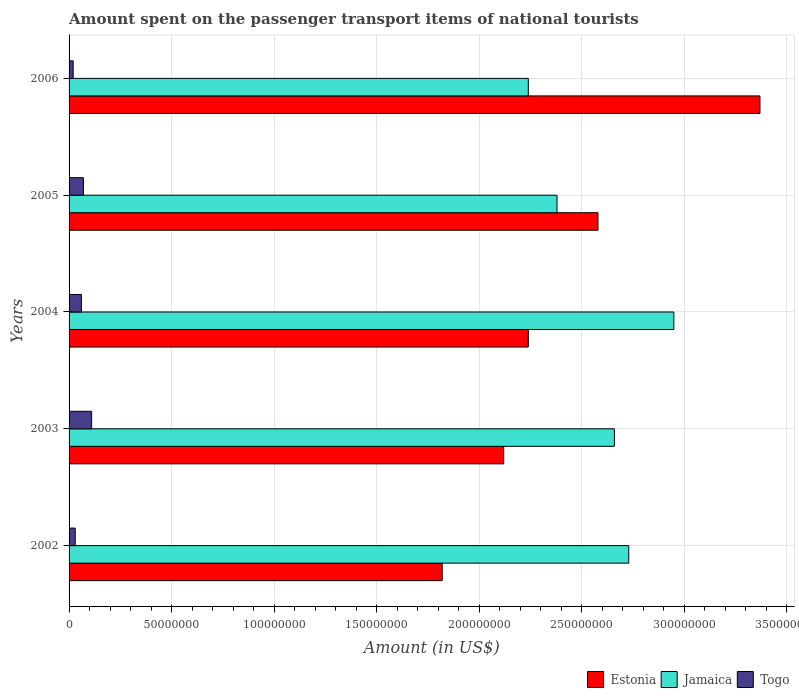What is the label of the 1st group of bars from the top?
Your answer should be compact. 2006. What is the amount spent on the passenger transport items of national tourists in Estonia in 2006?
Your answer should be compact. 3.37e+08. Across all years, what is the maximum amount spent on the passenger transport items of national tourists in Jamaica?
Offer a terse response. 2.95e+08. Across all years, what is the minimum amount spent on the passenger transport items of national tourists in Estonia?
Your answer should be compact. 1.82e+08. In which year was the amount spent on the passenger transport items of national tourists in Estonia maximum?
Your response must be concise. 2006. In which year was the amount spent on the passenger transport items of national tourists in Jamaica minimum?
Keep it short and to the point. 2006. What is the total amount spent on the passenger transport items of national tourists in Estonia in the graph?
Your answer should be very brief. 1.21e+09. What is the difference between the amount spent on the passenger transport items of national tourists in Jamaica in 2002 and that in 2005?
Your response must be concise. 3.50e+07. What is the difference between the amount spent on the passenger transport items of national tourists in Estonia in 2004 and the amount spent on the passenger transport items of national tourists in Jamaica in 2006?
Offer a terse response. 0. What is the average amount spent on the passenger transport items of national tourists in Togo per year?
Your response must be concise. 5.80e+06. In the year 2002, what is the difference between the amount spent on the passenger transport items of national tourists in Togo and amount spent on the passenger transport items of national tourists in Jamaica?
Ensure brevity in your answer.  -2.70e+08. In how many years, is the amount spent on the passenger transport items of national tourists in Estonia greater than 120000000 US$?
Your answer should be compact. 5. What is the ratio of the amount spent on the passenger transport items of national tourists in Estonia in 2002 to that in 2003?
Your response must be concise. 0.86. What is the difference between the highest and the second highest amount spent on the passenger transport items of national tourists in Estonia?
Your answer should be very brief. 7.90e+07. What is the difference between the highest and the lowest amount spent on the passenger transport items of national tourists in Togo?
Offer a terse response. 9.00e+06. Is the sum of the amount spent on the passenger transport items of national tourists in Togo in 2003 and 2006 greater than the maximum amount spent on the passenger transport items of national tourists in Estonia across all years?
Your response must be concise. No. What does the 3rd bar from the top in 2003 represents?
Your answer should be very brief. Estonia. What does the 2nd bar from the bottom in 2003 represents?
Make the answer very short. Jamaica. How many bars are there?
Offer a terse response. 15. Are the values on the major ticks of X-axis written in scientific E-notation?
Offer a terse response. No. Does the graph contain any zero values?
Make the answer very short. No. Where does the legend appear in the graph?
Your response must be concise. Bottom right. What is the title of the graph?
Provide a succinct answer. Amount spent on the passenger transport items of national tourists. What is the label or title of the Y-axis?
Ensure brevity in your answer.  Years. What is the Amount (in US$) of Estonia in 2002?
Your answer should be very brief. 1.82e+08. What is the Amount (in US$) in Jamaica in 2002?
Your answer should be very brief. 2.73e+08. What is the Amount (in US$) in Estonia in 2003?
Keep it short and to the point. 2.12e+08. What is the Amount (in US$) in Jamaica in 2003?
Provide a succinct answer. 2.66e+08. What is the Amount (in US$) in Togo in 2003?
Offer a very short reply. 1.10e+07. What is the Amount (in US$) of Estonia in 2004?
Your answer should be very brief. 2.24e+08. What is the Amount (in US$) in Jamaica in 2004?
Your response must be concise. 2.95e+08. What is the Amount (in US$) in Estonia in 2005?
Provide a short and direct response. 2.58e+08. What is the Amount (in US$) of Jamaica in 2005?
Offer a terse response. 2.38e+08. What is the Amount (in US$) of Togo in 2005?
Provide a succinct answer. 7.00e+06. What is the Amount (in US$) in Estonia in 2006?
Offer a terse response. 3.37e+08. What is the Amount (in US$) of Jamaica in 2006?
Keep it short and to the point. 2.24e+08. Across all years, what is the maximum Amount (in US$) in Estonia?
Ensure brevity in your answer.  3.37e+08. Across all years, what is the maximum Amount (in US$) of Jamaica?
Give a very brief answer. 2.95e+08. Across all years, what is the maximum Amount (in US$) in Togo?
Offer a terse response. 1.10e+07. Across all years, what is the minimum Amount (in US$) in Estonia?
Your answer should be compact. 1.82e+08. Across all years, what is the minimum Amount (in US$) of Jamaica?
Ensure brevity in your answer.  2.24e+08. What is the total Amount (in US$) of Estonia in the graph?
Offer a very short reply. 1.21e+09. What is the total Amount (in US$) of Jamaica in the graph?
Provide a succinct answer. 1.30e+09. What is the total Amount (in US$) in Togo in the graph?
Keep it short and to the point. 2.90e+07. What is the difference between the Amount (in US$) of Estonia in 2002 and that in 2003?
Provide a succinct answer. -3.00e+07. What is the difference between the Amount (in US$) of Togo in 2002 and that in 2003?
Offer a terse response. -8.00e+06. What is the difference between the Amount (in US$) in Estonia in 2002 and that in 2004?
Your answer should be very brief. -4.20e+07. What is the difference between the Amount (in US$) in Jamaica in 2002 and that in 2004?
Give a very brief answer. -2.20e+07. What is the difference between the Amount (in US$) in Estonia in 2002 and that in 2005?
Your response must be concise. -7.60e+07. What is the difference between the Amount (in US$) of Jamaica in 2002 and that in 2005?
Your answer should be very brief. 3.50e+07. What is the difference between the Amount (in US$) in Estonia in 2002 and that in 2006?
Give a very brief answer. -1.55e+08. What is the difference between the Amount (in US$) of Jamaica in 2002 and that in 2006?
Provide a succinct answer. 4.90e+07. What is the difference between the Amount (in US$) in Estonia in 2003 and that in 2004?
Keep it short and to the point. -1.20e+07. What is the difference between the Amount (in US$) in Jamaica in 2003 and that in 2004?
Provide a succinct answer. -2.90e+07. What is the difference between the Amount (in US$) in Estonia in 2003 and that in 2005?
Your answer should be compact. -4.60e+07. What is the difference between the Amount (in US$) of Jamaica in 2003 and that in 2005?
Provide a short and direct response. 2.80e+07. What is the difference between the Amount (in US$) of Estonia in 2003 and that in 2006?
Offer a terse response. -1.25e+08. What is the difference between the Amount (in US$) of Jamaica in 2003 and that in 2006?
Make the answer very short. 4.20e+07. What is the difference between the Amount (in US$) in Togo in 2003 and that in 2006?
Provide a succinct answer. 9.00e+06. What is the difference between the Amount (in US$) in Estonia in 2004 and that in 2005?
Give a very brief answer. -3.40e+07. What is the difference between the Amount (in US$) in Jamaica in 2004 and that in 2005?
Offer a very short reply. 5.70e+07. What is the difference between the Amount (in US$) in Estonia in 2004 and that in 2006?
Offer a very short reply. -1.13e+08. What is the difference between the Amount (in US$) of Jamaica in 2004 and that in 2006?
Your response must be concise. 7.10e+07. What is the difference between the Amount (in US$) in Togo in 2004 and that in 2006?
Offer a terse response. 4.00e+06. What is the difference between the Amount (in US$) in Estonia in 2005 and that in 2006?
Your answer should be compact. -7.90e+07. What is the difference between the Amount (in US$) in Jamaica in 2005 and that in 2006?
Provide a succinct answer. 1.40e+07. What is the difference between the Amount (in US$) in Estonia in 2002 and the Amount (in US$) in Jamaica in 2003?
Your answer should be very brief. -8.40e+07. What is the difference between the Amount (in US$) in Estonia in 2002 and the Amount (in US$) in Togo in 2003?
Your answer should be compact. 1.71e+08. What is the difference between the Amount (in US$) of Jamaica in 2002 and the Amount (in US$) of Togo in 2003?
Offer a terse response. 2.62e+08. What is the difference between the Amount (in US$) in Estonia in 2002 and the Amount (in US$) in Jamaica in 2004?
Make the answer very short. -1.13e+08. What is the difference between the Amount (in US$) of Estonia in 2002 and the Amount (in US$) of Togo in 2004?
Ensure brevity in your answer.  1.76e+08. What is the difference between the Amount (in US$) of Jamaica in 2002 and the Amount (in US$) of Togo in 2004?
Your response must be concise. 2.67e+08. What is the difference between the Amount (in US$) of Estonia in 2002 and the Amount (in US$) of Jamaica in 2005?
Ensure brevity in your answer.  -5.60e+07. What is the difference between the Amount (in US$) in Estonia in 2002 and the Amount (in US$) in Togo in 2005?
Ensure brevity in your answer.  1.75e+08. What is the difference between the Amount (in US$) in Jamaica in 2002 and the Amount (in US$) in Togo in 2005?
Provide a short and direct response. 2.66e+08. What is the difference between the Amount (in US$) in Estonia in 2002 and the Amount (in US$) in Jamaica in 2006?
Ensure brevity in your answer.  -4.20e+07. What is the difference between the Amount (in US$) in Estonia in 2002 and the Amount (in US$) in Togo in 2006?
Provide a short and direct response. 1.80e+08. What is the difference between the Amount (in US$) in Jamaica in 2002 and the Amount (in US$) in Togo in 2006?
Provide a succinct answer. 2.71e+08. What is the difference between the Amount (in US$) in Estonia in 2003 and the Amount (in US$) in Jamaica in 2004?
Your response must be concise. -8.30e+07. What is the difference between the Amount (in US$) of Estonia in 2003 and the Amount (in US$) of Togo in 2004?
Keep it short and to the point. 2.06e+08. What is the difference between the Amount (in US$) in Jamaica in 2003 and the Amount (in US$) in Togo in 2004?
Your answer should be very brief. 2.60e+08. What is the difference between the Amount (in US$) of Estonia in 2003 and the Amount (in US$) of Jamaica in 2005?
Keep it short and to the point. -2.60e+07. What is the difference between the Amount (in US$) in Estonia in 2003 and the Amount (in US$) in Togo in 2005?
Offer a very short reply. 2.05e+08. What is the difference between the Amount (in US$) of Jamaica in 2003 and the Amount (in US$) of Togo in 2005?
Your answer should be compact. 2.59e+08. What is the difference between the Amount (in US$) of Estonia in 2003 and the Amount (in US$) of Jamaica in 2006?
Keep it short and to the point. -1.20e+07. What is the difference between the Amount (in US$) of Estonia in 2003 and the Amount (in US$) of Togo in 2006?
Keep it short and to the point. 2.10e+08. What is the difference between the Amount (in US$) in Jamaica in 2003 and the Amount (in US$) in Togo in 2006?
Make the answer very short. 2.64e+08. What is the difference between the Amount (in US$) in Estonia in 2004 and the Amount (in US$) in Jamaica in 2005?
Offer a terse response. -1.40e+07. What is the difference between the Amount (in US$) of Estonia in 2004 and the Amount (in US$) of Togo in 2005?
Your answer should be very brief. 2.17e+08. What is the difference between the Amount (in US$) in Jamaica in 2004 and the Amount (in US$) in Togo in 2005?
Provide a short and direct response. 2.88e+08. What is the difference between the Amount (in US$) in Estonia in 2004 and the Amount (in US$) in Jamaica in 2006?
Ensure brevity in your answer.  0. What is the difference between the Amount (in US$) in Estonia in 2004 and the Amount (in US$) in Togo in 2006?
Your answer should be very brief. 2.22e+08. What is the difference between the Amount (in US$) of Jamaica in 2004 and the Amount (in US$) of Togo in 2006?
Provide a short and direct response. 2.93e+08. What is the difference between the Amount (in US$) of Estonia in 2005 and the Amount (in US$) of Jamaica in 2006?
Your response must be concise. 3.40e+07. What is the difference between the Amount (in US$) in Estonia in 2005 and the Amount (in US$) in Togo in 2006?
Offer a very short reply. 2.56e+08. What is the difference between the Amount (in US$) of Jamaica in 2005 and the Amount (in US$) of Togo in 2006?
Ensure brevity in your answer.  2.36e+08. What is the average Amount (in US$) in Estonia per year?
Make the answer very short. 2.43e+08. What is the average Amount (in US$) of Jamaica per year?
Your response must be concise. 2.59e+08. What is the average Amount (in US$) in Togo per year?
Provide a short and direct response. 5.80e+06. In the year 2002, what is the difference between the Amount (in US$) in Estonia and Amount (in US$) in Jamaica?
Provide a short and direct response. -9.10e+07. In the year 2002, what is the difference between the Amount (in US$) in Estonia and Amount (in US$) in Togo?
Your response must be concise. 1.79e+08. In the year 2002, what is the difference between the Amount (in US$) in Jamaica and Amount (in US$) in Togo?
Provide a succinct answer. 2.70e+08. In the year 2003, what is the difference between the Amount (in US$) in Estonia and Amount (in US$) in Jamaica?
Your response must be concise. -5.40e+07. In the year 2003, what is the difference between the Amount (in US$) of Estonia and Amount (in US$) of Togo?
Give a very brief answer. 2.01e+08. In the year 2003, what is the difference between the Amount (in US$) in Jamaica and Amount (in US$) in Togo?
Your answer should be compact. 2.55e+08. In the year 2004, what is the difference between the Amount (in US$) in Estonia and Amount (in US$) in Jamaica?
Your answer should be compact. -7.10e+07. In the year 2004, what is the difference between the Amount (in US$) of Estonia and Amount (in US$) of Togo?
Your answer should be compact. 2.18e+08. In the year 2004, what is the difference between the Amount (in US$) of Jamaica and Amount (in US$) of Togo?
Provide a short and direct response. 2.89e+08. In the year 2005, what is the difference between the Amount (in US$) in Estonia and Amount (in US$) in Jamaica?
Provide a short and direct response. 2.00e+07. In the year 2005, what is the difference between the Amount (in US$) in Estonia and Amount (in US$) in Togo?
Keep it short and to the point. 2.51e+08. In the year 2005, what is the difference between the Amount (in US$) of Jamaica and Amount (in US$) of Togo?
Give a very brief answer. 2.31e+08. In the year 2006, what is the difference between the Amount (in US$) of Estonia and Amount (in US$) of Jamaica?
Provide a short and direct response. 1.13e+08. In the year 2006, what is the difference between the Amount (in US$) of Estonia and Amount (in US$) of Togo?
Ensure brevity in your answer.  3.35e+08. In the year 2006, what is the difference between the Amount (in US$) of Jamaica and Amount (in US$) of Togo?
Ensure brevity in your answer.  2.22e+08. What is the ratio of the Amount (in US$) in Estonia in 2002 to that in 2003?
Keep it short and to the point. 0.86. What is the ratio of the Amount (in US$) of Jamaica in 2002 to that in 2003?
Ensure brevity in your answer.  1.03. What is the ratio of the Amount (in US$) in Togo in 2002 to that in 2003?
Make the answer very short. 0.27. What is the ratio of the Amount (in US$) in Estonia in 2002 to that in 2004?
Provide a succinct answer. 0.81. What is the ratio of the Amount (in US$) in Jamaica in 2002 to that in 2004?
Make the answer very short. 0.93. What is the ratio of the Amount (in US$) of Estonia in 2002 to that in 2005?
Offer a terse response. 0.71. What is the ratio of the Amount (in US$) of Jamaica in 2002 to that in 2005?
Offer a very short reply. 1.15. What is the ratio of the Amount (in US$) in Togo in 2002 to that in 2005?
Offer a terse response. 0.43. What is the ratio of the Amount (in US$) in Estonia in 2002 to that in 2006?
Make the answer very short. 0.54. What is the ratio of the Amount (in US$) of Jamaica in 2002 to that in 2006?
Your answer should be very brief. 1.22. What is the ratio of the Amount (in US$) of Estonia in 2003 to that in 2004?
Provide a short and direct response. 0.95. What is the ratio of the Amount (in US$) of Jamaica in 2003 to that in 2004?
Your answer should be compact. 0.9. What is the ratio of the Amount (in US$) in Togo in 2003 to that in 2004?
Ensure brevity in your answer.  1.83. What is the ratio of the Amount (in US$) in Estonia in 2003 to that in 2005?
Offer a very short reply. 0.82. What is the ratio of the Amount (in US$) in Jamaica in 2003 to that in 2005?
Keep it short and to the point. 1.12. What is the ratio of the Amount (in US$) of Togo in 2003 to that in 2005?
Offer a very short reply. 1.57. What is the ratio of the Amount (in US$) in Estonia in 2003 to that in 2006?
Provide a succinct answer. 0.63. What is the ratio of the Amount (in US$) in Jamaica in 2003 to that in 2006?
Provide a short and direct response. 1.19. What is the ratio of the Amount (in US$) in Togo in 2003 to that in 2006?
Your response must be concise. 5.5. What is the ratio of the Amount (in US$) in Estonia in 2004 to that in 2005?
Offer a very short reply. 0.87. What is the ratio of the Amount (in US$) in Jamaica in 2004 to that in 2005?
Make the answer very short. 1.24. What is the ratio of the Amount (in US$) of Togo in 2004 to that in 2005?
Offer a very short reply. 0.86. What is the ratio of the Amount (in US$) of Estonia in 2004 to that in 2006?
Provide a succinct answer. 0.66. What is the ratio of the Amount (in US$) in Jamaica in 2004 to that in 2006?
Ensure brevity in your answer.  1.32. What is the ratio of the Amount (in US$) of Togo in 2004 to that in 2006?
Your response must be concise. 3. What is the ratio of the Amount (in US$) of Estonia in 2005 to that in 2006?
Your answer should be compact. 0.77. What is the ratio of the Amount (in US$) of Jamaica in 2005 to that in 2006?
Offer a very short reply. 1.06. What is the ratio of the Amount (in US$) in Togo in 2005 to that in 2006?
Your answer should be very brief. 3.5. What is the difference between the highest and the second highest Amount (in US$) of Estonia?
Your answer should be compact. 7.90e+07. What is the difference between the highest and the second highest Amount (in US$) in Jamaica?
Ensure brevity in your answer.  2.20e+07. What is the difference between the highest and the second highest Amount (in US$) of Togo?
Make the answer very short. 4.00e+06. What is the difference between the highest and the lowest Amount (in US$) in Estonia?
Make the answer very short. 1.55e+08. What is the difference between the highest and the lowest Amount (in US$) of Jamaica?
Your answer should be compact. 7.10e+07. What is the difference between the highest and the lowest Amount (in US$) of Togo?
Keep it short and to the point. 9.00e+06. 